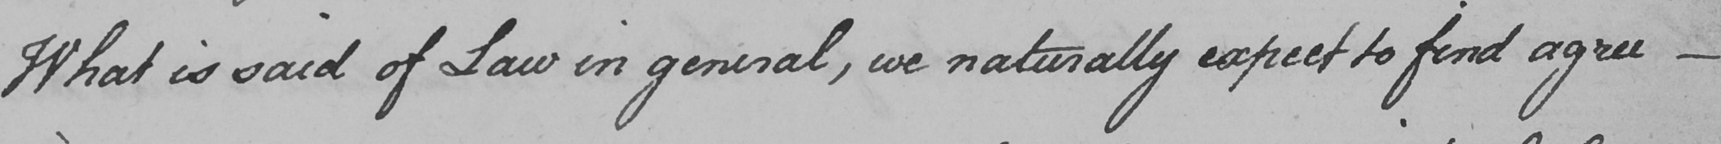What text is written in this handwritten line? What is said of Law in general , we naturally expect to find agree  _ 